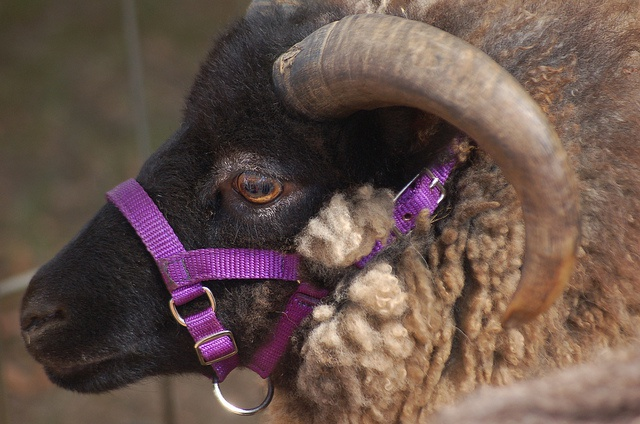Describe the objects in this image and their specific colors. I can see a sheep in black, gray, and tan tones in this image. 